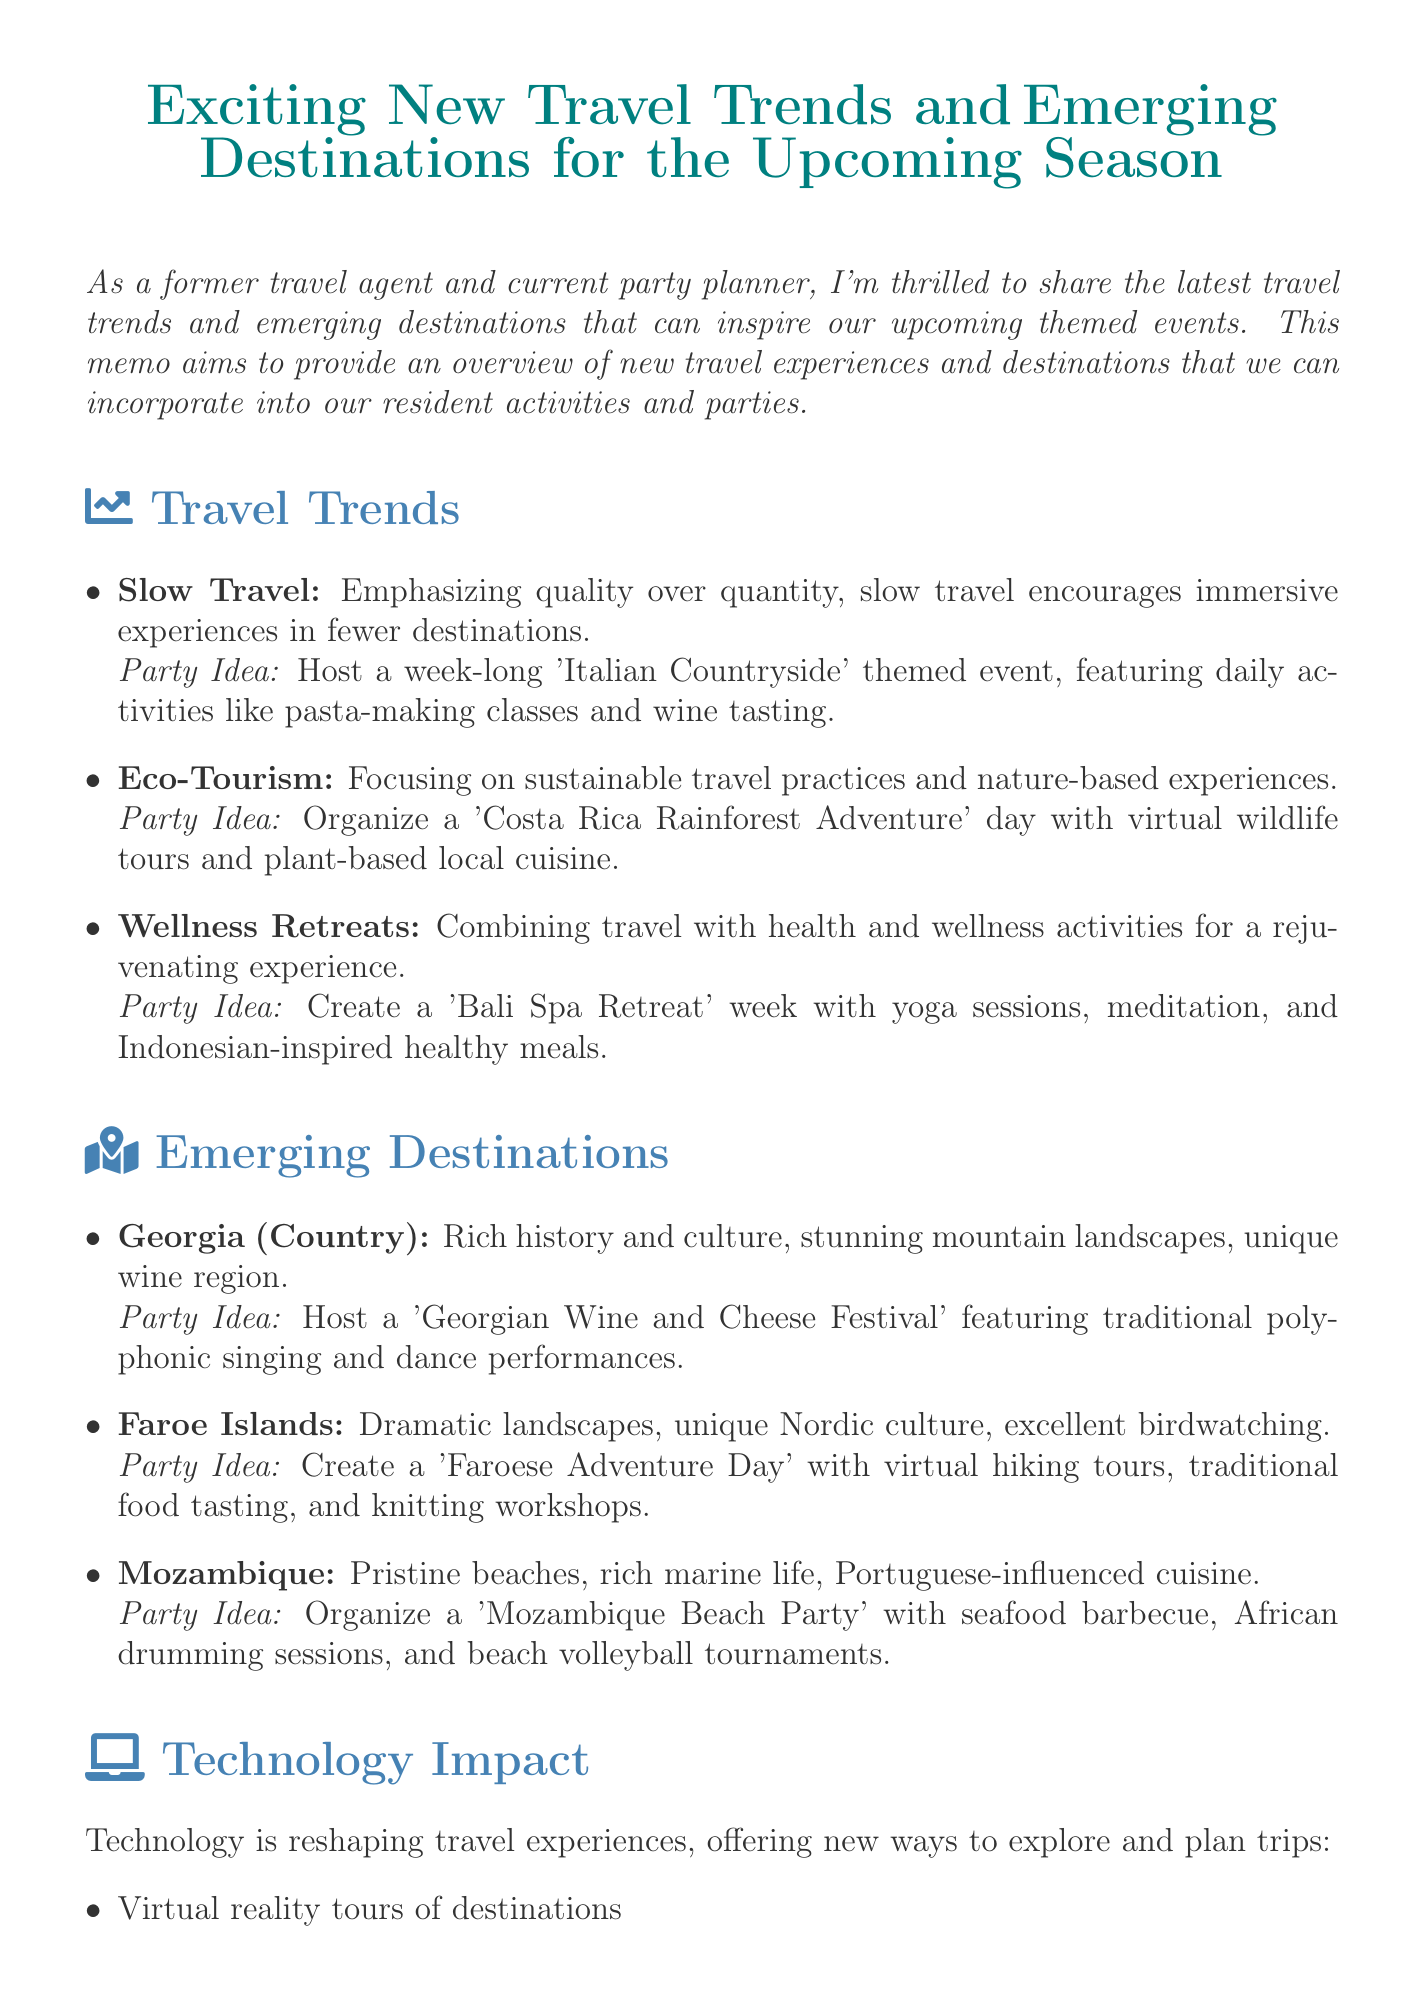what is the title of the memo? The title of the memo is presented prominently at the top of the document.
Answer: Exciting New Travel Trends and Emerging Destinations for the Upcoming Season what is a trend highlighted in the document? The document lists several trends, which are clearly outlined within the travel trends section.
Answer: Slow Travel what is an emerging destination mentioned? The memo describes specific emerging destinations under the respective section in the document.
Answer: Georgia (Country) how many travel trends are discussed in the memo? The document enumerates the trends, providing a list format in the travel trends section.
Answer: 3 what party idea is associated with Eco-Tourism? Each trend is linked to a specific party idea, detailed in the same section.
Answer: Organize a 'Costa Rica Rainforest Adventure' day with virtual wildlife tours and plant-based local cuisine which destination is suggested for a 'Mozambique Beach Party'? The destinations and their party ideas are mentioned in the emerging destinations section of the document.
Answer: Mozambique what technology trend is reshaping travel experiences? The technology impact section mentions various technological changes affecting travel.
Answer: Virtual reality tours of destinations what is the summary of the memo? The conclusion provides a summary of the memo's content and overall message.
Answer: These new travel trends and emerging destinations offer exciting opportunities for creating unique and engaging experiences for our residents 